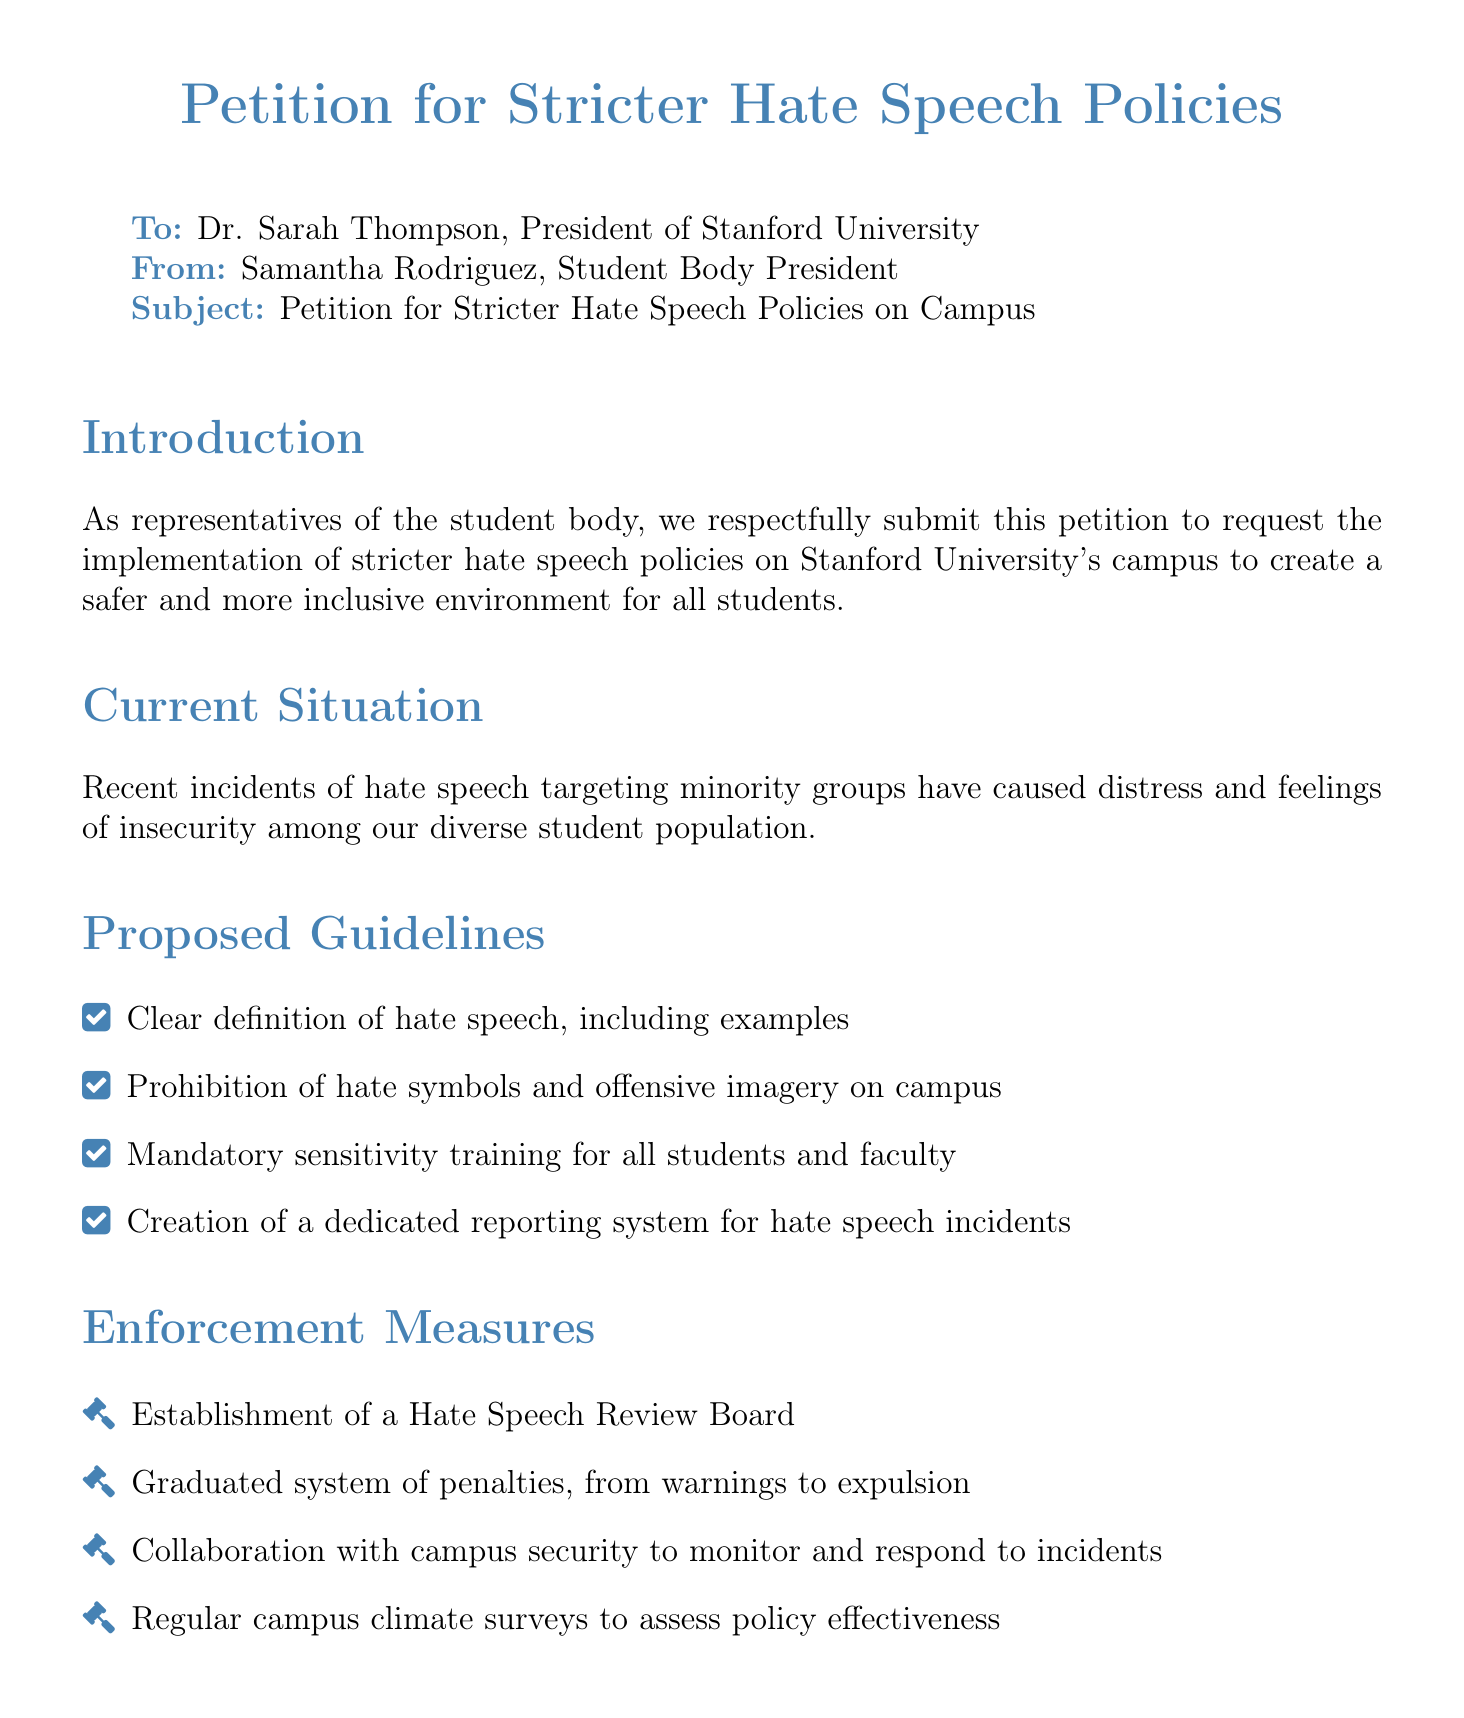What is the title of the petition? The title is prominently stated at the beginning of the document, indicating its subject matter clearly.
Answer: Petition for Stricter Hate Speech Policies Who is the petition addressed to? The recipient of the petition is specified in the "To" section at the beginning of the document.
Answer: Dr. Sarah Thompson How many signatures does the petition have? The number of signatures is mentioned in the closing statement of the document.
Answer: 2,500 What is one of the proposed guidelines for hate speech policies? The proposed guidelines include specific actions meant to address hate speech, listed in the guidelines section.
Answer: Mandatory sensitivity training for all students and faculty What is the purpose of the Hate Speech Review Board? The board is part of enforcement measures designed to address incidents of hate speech, mentioned in the corresponding section of the document.
Answer: To review hate speech incidents What is one benefit of implementing stricter hate speech policies? The benefits outlined highlight positive outcomes for the university community, listed towards the end of the document.
Answer: Fostering a more harmonious learning environment What type of training is proposed for all students and faculty? The specific type of training focuses on increasing awareness and understanding of sensitive topics, indicated in the guidelines section.
Answer: Sensitivity training What is the response expected from the university administration? The closing section clarifies the desired outcome of submitting the petition to the administration.
Answer: Swift action 